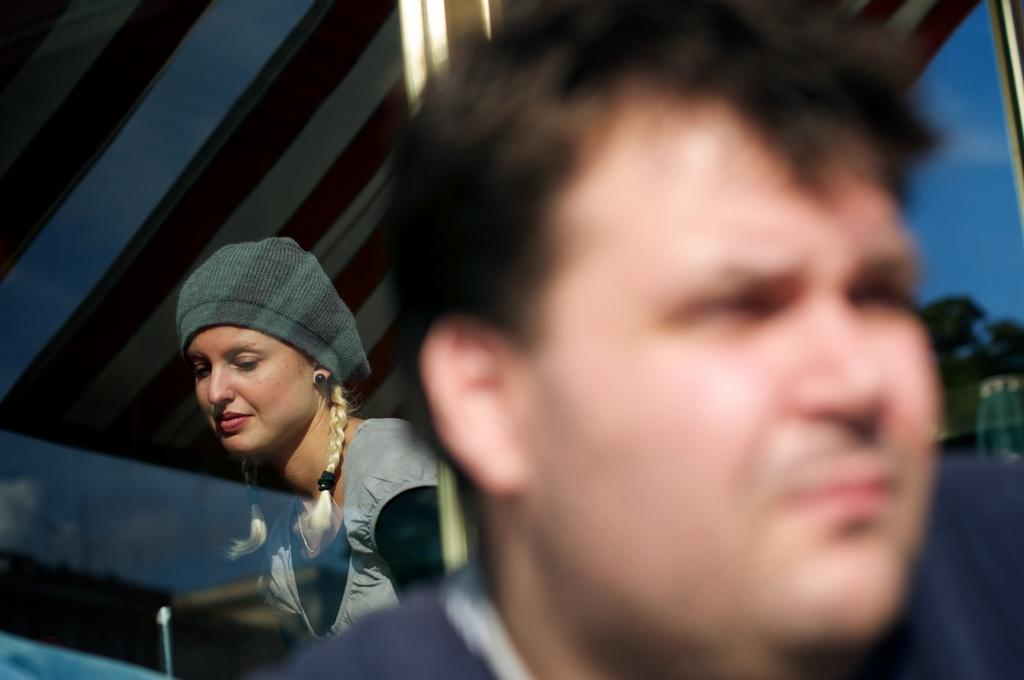What is the gender of the person on the right side of the image? There is a man on the right side of the image. What is the woman on the left side of the image wearing? The woman on the left side of the image is wearing a cap. What type of vegetation can be seen in the image? There are trees visible in the image. What is visible in the sky in the image? There are clouds in the sky in the image. What type of lettuce is being used to make jam in the image? There is no lettuce or jam present in the image. How many cars can be seen in the image? There are no cars visible in the image. 